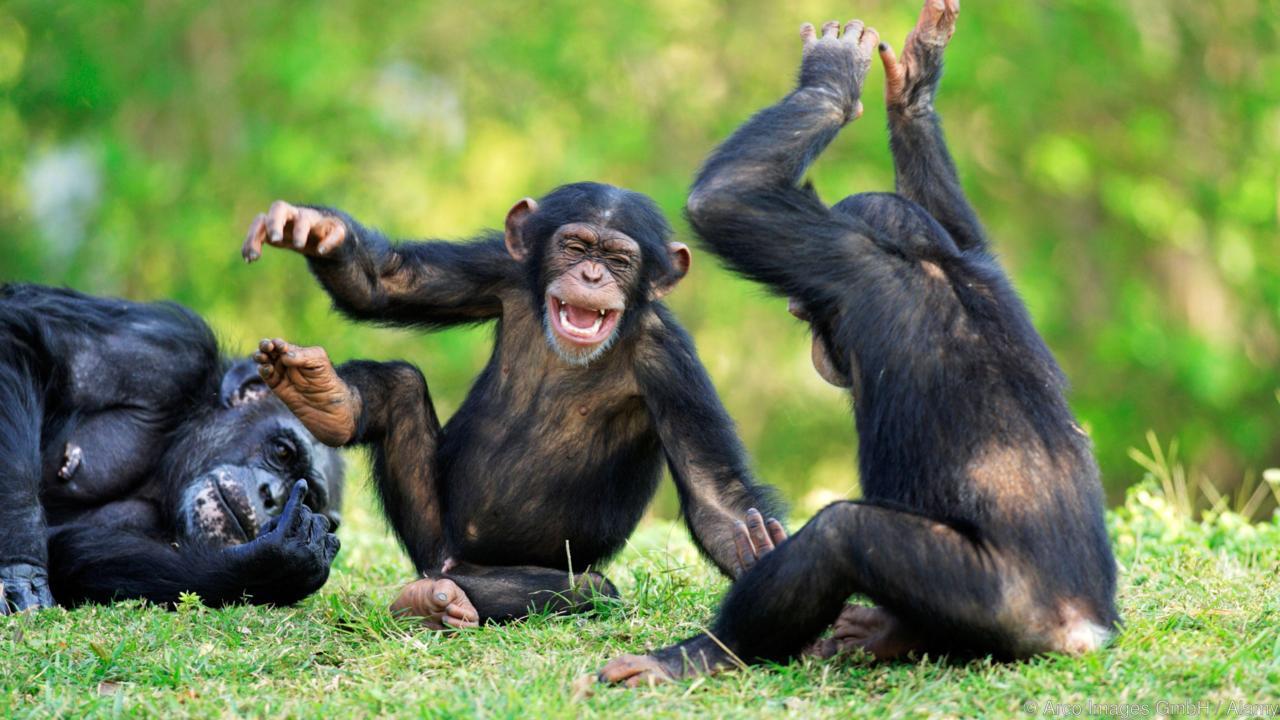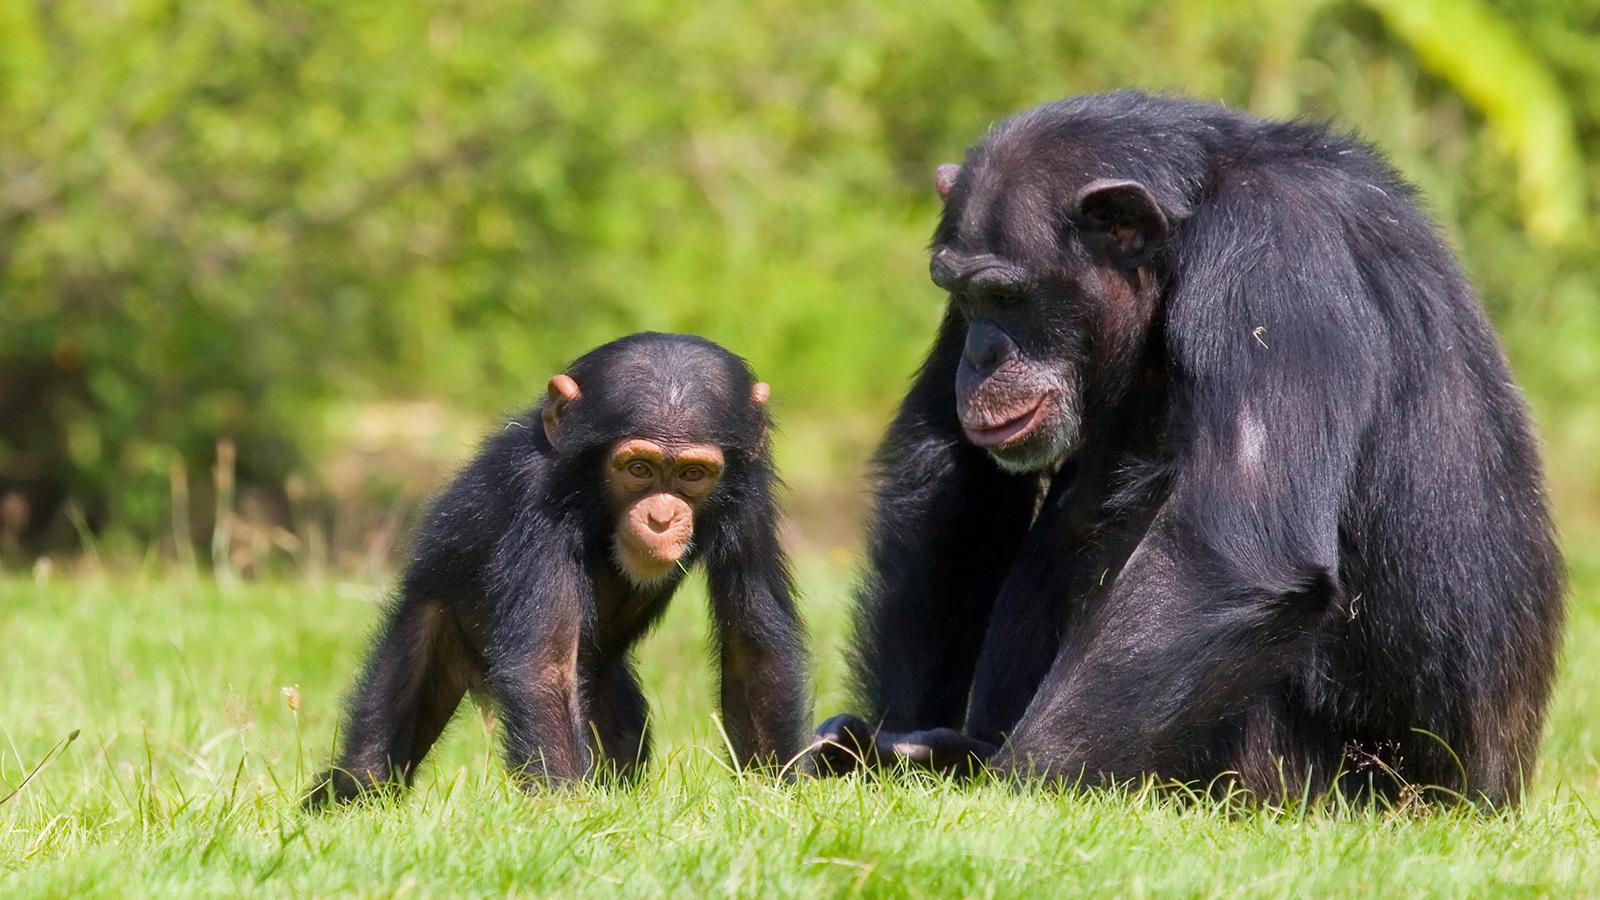The first image is the image on the left, the second image is the image on the right. Examine the images to the left and right. Is the description "There is exactly one animal in the image on the right." accurate? Answer yes or no. No. The first image is the image on the left, the second image is the image on the right. Analyze the images presented: Is the assertion "One image shows two chimpanzees sitting in the grass together." valid? Answer yes or no. Yes. 